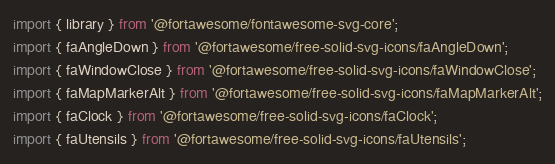<code> <loc_0><loc_0><loc_500><loc_500><_JavaScript_>import { library } from '@fortawesome/fontawesome-svg-core';
import { faAngleDown } from '@fortawesome/free-solid-svg-icons/faAngleDown';
import { faWindowClose } from '@fortawesome/free-solid-svg-icons/faWindowClose';
import { faMapMarkerAlt } from '@fortawesome/free-solid-svg-icons/faMapMarkerAlt';
import { faClock } from '@fortawesome/free-solid-svg-icons/faClock';
import { faUtensils } from '@fortawesome/free-solid-svg-icons/faUtensils';</code> 